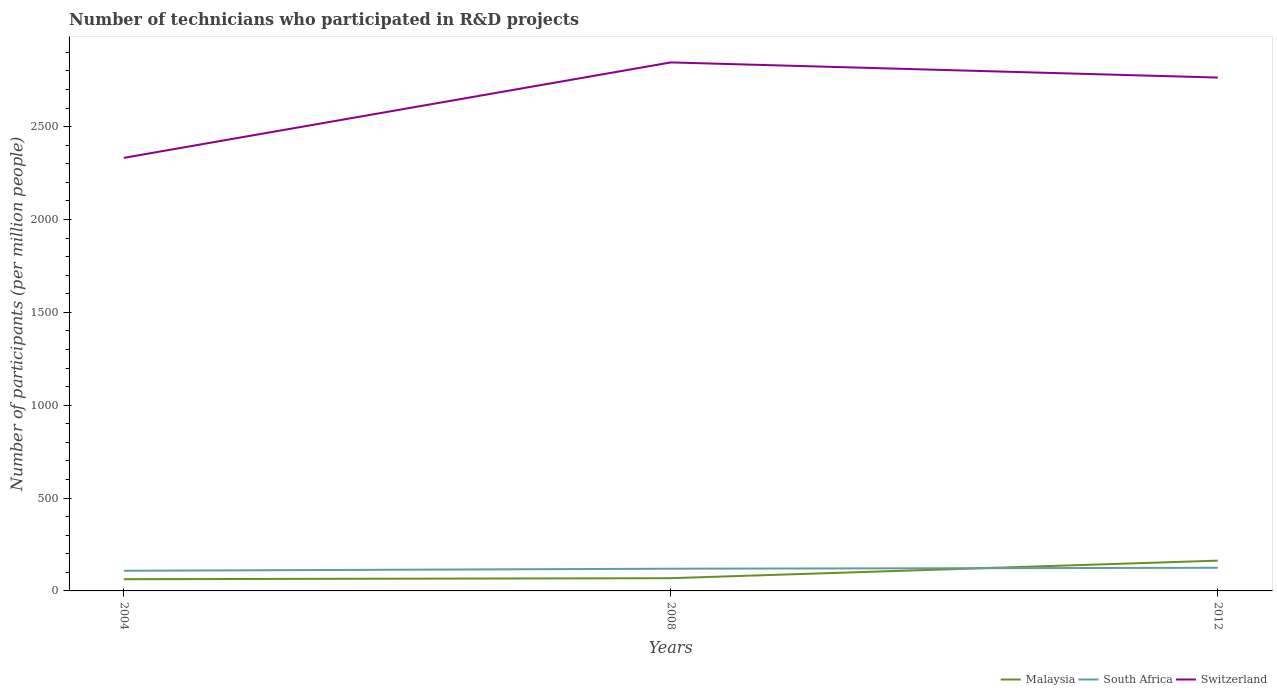How many different coloured lines are there?
Your response must be concise. 3. Does the line corresponding to South Africa intersect with the line corresponding to Switzerland?
Your answer should be compact. No. Is the number of lines equal to the number of legend labels?
Offer a terse response. Yes. Across all years, what is the maximum number of technicians who participated in R&D projects in Switzerland?
Offer a very short reply. 2332.1. What is the total number of technicians who participated in R&D projects in Malaysia in the graph?
Your response must be concise. -100.03. What is the difference between the highest and the second highest number of technicians who participated in R&D projects in Malaysia?
Give a very brief answer. 100.03. Is the number of technicians who participated in R&D projects in South Africa strictly greater than the number of technicians who participated in R&D projects in Switzerland over the years?
Provide a succinct answer. Yes. How many lines are there?
Ensure brevity in your answer.  3. How many years are there in the graph?
Provide a short and direct response. 3. Are the values on the major ticks of Y-axis written in scientific E-notation?
Offer a very short reply. No. Does the graph contain any zero values?
Your answer should be very brief. No. What is the title of the graph?
Offer a terse response. Number of technicians who participated in R&D projects. Does "Albania" appear as one of the legend labels in the graph?
Your answer should be very brief. No. What is the label or title of the Y-axis?
Make the answer very short. Number of participants (per million people). What is the Number of participants (per million people) in Malaysia in 2004?
Your answer should be very brief. 63.07. What is the Number of participants (per million people) of South Africa in 2004?
Provide a short and direct response. 108.58. What is the Number of participants (per million people) of Switzerland in 2004?
Ensure brevity in your answer.  2332.1. What is the Number of participants (per million people) in Malaysia in 2008?
Give a very brief answer. 68.57. What is the Number of participants (per million people) of South Africa in 2008?
Keep it short and to the point. 119.61. What is the Number of participants (per million people) of Switzerland in 2008?
Provide a short and direct response. 2846.06. What is the Number of participants (per million people) of Malaysia in 2012?
Keep it short and to the point. 163.1. What is the Number of participants (per million people) in South Africa in 2012?
Offer a terse response. 124.58. What is the Number of participants (per million people) of Switzerland in 2012?
Keep it short and to the point. 2764.52. Across all years, what is the maximum Number of participants (per million people) in Malaysia?
Give a very brief answer. 163.1. Across all years, what is the maximum Number of participants (per million people) of South Africa?
Provide a short and direct response. 124.58. Across all years, what is the maximum Number of participants (per million people) of Switzerland?
Provide a short and direct response. 2846.06. Across all years, what is the minimum Number of participants (per million people) in Malaysia?
Provide a succinct answer. 63.07. Across all years, what is the minimum Number of participants (per million people) of South Africa?
Make the answer very short. 108.58. Across all years, what is the minimum Number of participants (per million people) of Switzerland?
Your answer should be very brief. 2332.1. What is the total Number of participants (per million people) in Malaysia in the graph?
Your response must be concise. 294.75. What is the total Number of participants (per million people) in South Africa in the graph?
Give a very brief answer. 352.77. What is the total Number of participants (per million people) in Switzerland in the graph?
Offer a terse response. 7942.69. What is the difference between the Number of participants (per million people) of Malaysia in 2004 and that in 2008?
Offer a terse response. -5.5. What is the difference between the Number of participants (per million people) of South Africa in 2004 and that in 2008?
Provide a short and direct response. -11.03. What is the difference between the Number of participants (per million people) of Switzerland in 2004 and that in 2008?
Provide a succinct answer. -513.96. What is the difference between the Number of participants (per million people) in Malaysia in 2004 and that in 2012?
Give a very brief answer. -100.03. What is the difference between the Number of participants (per million people) of South Africa in 2004 and that in 2012?
Give a very brief answer. -16. What is the difference between the Number of participants (per million people) in Switzerland in 2004 and that in 2012?
Ensure brevity in your answer.  -432.42. What is the difference between the Number of participants (per million people) of Malaysia in 2008 and that in 2012?
Give a very brief answer. -94.53. What is the difference between the Number of participants (per million people) of South Africa in 2008 and that in 2012?
Provide a succinct answer. -4.97. What is the difference between the Number of participants (per million people) in Switzerland in 2008 and that in 2012?
Keep it short and to the point. 81.54. What is the difference between the Number of participants (per million people) of Malaysia in 2004 and the Number of participants (per million people) of South Africa in 2008?
Provide a succinct answer. -56.54. What is the difference between the Number of participants (per million people) in Malaysia in 2004 and the Number of participants (per million people) in Switzerland in 2008?
Ensure brevity in your answer.  -2782.99. What is the difference between the Number of participants (per million people) of South Africa in 2004 and the Number of participants (per million people) of Switzerland in 2008?
Give a very brief answer. -2737.48. What is the difference between the Number of participants (per million people) in Malaysia in 2004 and the Number of participants (per million people) in South Africa in 2012?
Your response must be concise. -61.5. What is the difference between the Number of participants (per million people) of Malaysia in 2004 and the Number of participants (per million people) of Switzerland in 2012?
Keep it short and to the point. -2701.45. What is the difference between the Number of participants (per million people) of South Africa in 2004 and the Number of participants (per million people) of Switzerland in 2012?
Offer a terse response. -2655.94. What is the difference between the Number of participants (per million people) in Malaysia in 2008 and the Number of participants (per million people) in South Africa in 2012?
Make the answer very short. -56. What is the difference between the Number of participants (per million people) of Malaysia in 2008 and the Number of participants (per million people) of Switzerland in 2012?
Ensure brevity in your answer.  -2695.95. What is the difference between the Number of participants (per million people) of South Africa in 2008 and the Number of participants (per million people) of Switzerland in 2012?
Your answer should be very brief. -2644.91. What is the average Number of participants (per million people) in Malaysia per year?
Your response must be concise. 98.25. What is the average Number of participants (per million people) in South Africa per year?
Keep it short and to the point. 117.59. What is the average Number of participants (per million people) in Switzerland per year?
Keep it short and to the point. 2647.56. In the year 2004, what is the difference between the Number of participants (per million people) of Malaysia and Number of participants (per million people) of South Africa?
Ensure brevity in your answer.  -45.51. In the year 2004, what is the difference between the Number of participants (per million people) of Malaysia and Number of participants (per million people) of Switzerland?
Your answer should be very brief. -2269.03. In the year 2004, what is the difference between the Number of participants (per million people) of South Africa and Number of participants (per million people) of Switzerland?
Give a very brief answer. -2223.52. In the year 2008, what is the difference between the Number of participants (per million people) in Malaysia and Number of participants (per million people) in South Africa?
Your response must be concise. -51.04. In the year 2008, what is the difference between the Number of participants (per million people) of Malaysia and Number of participants (per million people) of Switzerland?
Offer a terse response. -2777.49. In the year 2008, what is the difference between the Number of participants (per million people) of South Africa and Number of participants (per million people) of Switzerland?
Your response must be concise. -2726.45. In the year 2012, what is the difference between the Number of participants (per million people) in Malaysia and Number of participants (per million people) in South Africa?
Offer a very short reply. 38.53. In the year 2012, what is the difference between the Number of participants (per million people) of Malaysia and Number of participants (per million people) of Switzerland?
Ensure brevity in your answer.  -2601.42. In the year 2012, what is the difference between the Number of participants (per million people) in South Africa and Number of participants (per million people) in Switzerland?
Keep it short and to the point. -2639.94. What is the ratio of the Number of participants (per million people) of Malaysia in 2004 to that in 2008?
Keep it short and to the point. 0.92. What is the ratio of the Number of participants (per million people) in South Africa in 2004 to that in 2008?
Provide a short and direct response. 0.91. What is the ratio of the Number of participants (per million people) in Switzerland in 2004 to that in 2008?
Provide a short and direct response. 0.82. What is the ratio of the Number of participants (per million people) in Malaysia in 2004 to that in 2012?
Offer a very short reply. 0.39. What is the ratio of the Number of participants (per million people) of South Africa in 2004 to that in 2012?
Offer a terse response. 0.87. What is the ratio of the Number of participants (per million people) of Switzerland in 2004 to that in 2012?
Offer a very short reply. 0.84. What is the ratio of the Number of participants (per million people) of Malaysia in 2008 to that in 2012?
Provide a succinct answer. 0.42. What is the ratio of the Number of participants (per million people) in South Africa in 2008 to that in 2012?
Offer a terse response. 0.96. What is the ratio of the Number of participants (per million people) in Switzerland in 2008 to that in 2012?
Your answer should be very brief. 1.03. What is the difference between the highest and the second highest Number of participants (per million people) in Malaysia?
Your response must be concise. 94.53. What is the difference between the highest and the second highest Number of participants (per million people) of South Africa?
Offer a very short reply. 4.97. What is the difference between the highest and the second highest Number of participants (per million people) of Switzerland?
Your answer should be very brief. 81.54. What is the difference between the highest and the lowest Number of participants (per million people) in Malaysia?
Give a very brief answer. 100.03. What is the difference between the highest and the lowest Number of participants (per million people) in South Africa?
Give a very brief answer. 16. What is the difference between the highest and the lowest Number of participants (per million people) of Switzerland?
Give a very brief answer. 513.96. 